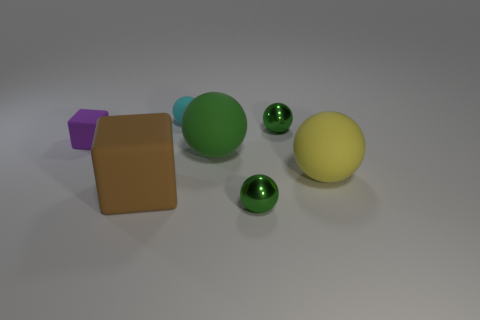Subtract all purple cubes. How many green spheres are left? 3 Subtract 2 spheres. How many spheres are left? 3 Subtract all cyan balls. How many balls are left? 4 Subtract all big yellow rubber spheres. How many spheres are left? 4 Subtract all brown spheres. Subtract all red cylinders. How many spheres are left? 5 Add 2 green metal blocks. How many objects exist? 9 Subtract all blocks. How many objects are left? 5 Subtract 0 green cubes. How many objects are left? 7 Subtract all big yellow rubber objects. Subtract all large blocks. How many objects are left? 5 Add 1 purple things. How many purple things are left? 2 